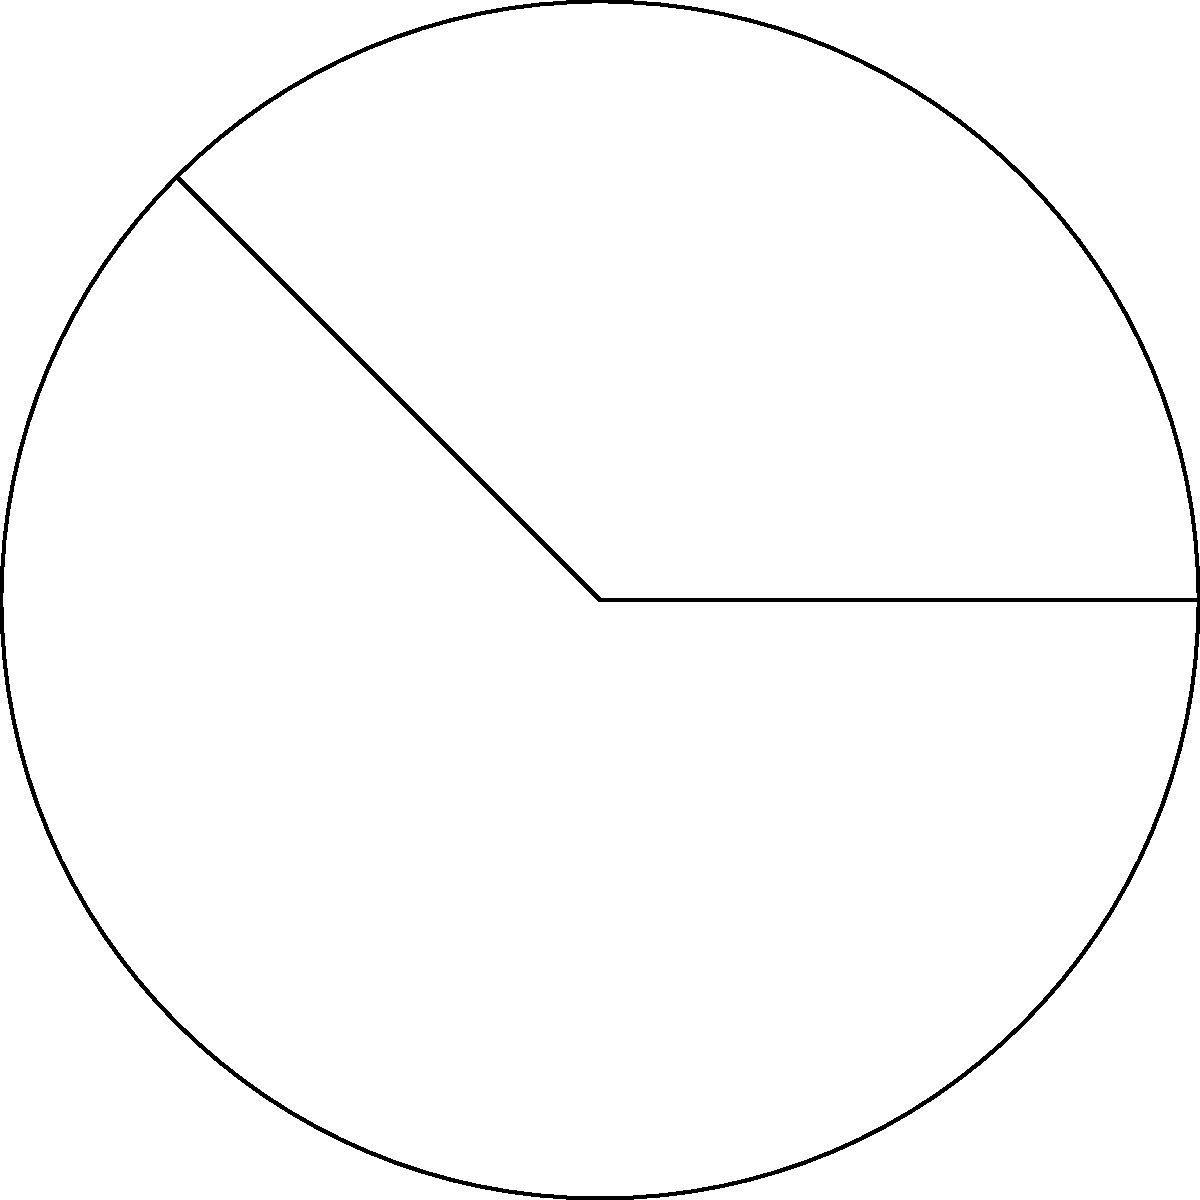During a halftime show, you need to march along a curved path that forms an arc of a circle. The radius of the circle is 30 yards, and the central angle of the arc is 135°. Calculate the length of the arc you need to march, rounded to the nearest yard. To find the arc length, we'll follow these steps:

1) The formula for arc length is:
   $$s = r\theta$$
   where $s$ is the arc length, $r$ is the radius, and $\theta$ is the central angle in radians.

2) We're given the radius $r = 30$ yards and the angle in degrees (135°).

3) First, we need to convert 135° to radians:
   $$\theta = 135° \times \frac{\pi}{180°} = \frac{3\pi}{4} \text{ radians}$$

4) Now we can plug these values into our arc length formula:
   $$s = r\theta = 30 \times \frac{3\pi}{4} = \frac{45\pi}{2} \approx 70.69 \text{ yards}$$

5) Rounding to the nearest yard:
   $$s \approx 71 \text{ yards}$$

Therefore, you need to march approximately 71 yards along this curved path.
Answer: 71 yards 